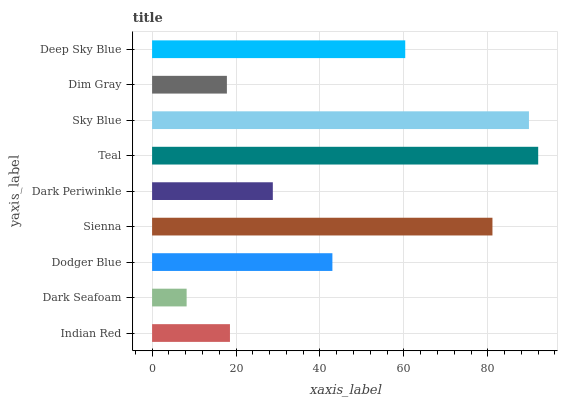Is Dark Seafoam the minimum?
Answer yes or no. Yes. Is Teal the maximum?
Answer yes or no. Yes. Is Dodger Blue the minimum?
Answer yes or no. No. Is Dodger Blue the maximum?
Answer yes or no. No. Is Dodger Blue greater than Dark Seafoam?
Answer yes or no. Yes. Is Dark Seafoam less than Dodger Blue?
Answer yes or no. Yes. Is Dark Seafoam greater than Dodger Blue?
Answer yes or no. No. Is Dodger Blue less than Dark Seafoam?
Answer yes or no. No. Is Dodger Blue the high median?
Answer yes or no. Yes. Is Dodger Blue the low median?
Answer yes or no. Yes. Is Sienna the high median?
Answer yes or no. No. Is Dark Periwinkle the low median?
Answer yes or no. No. 